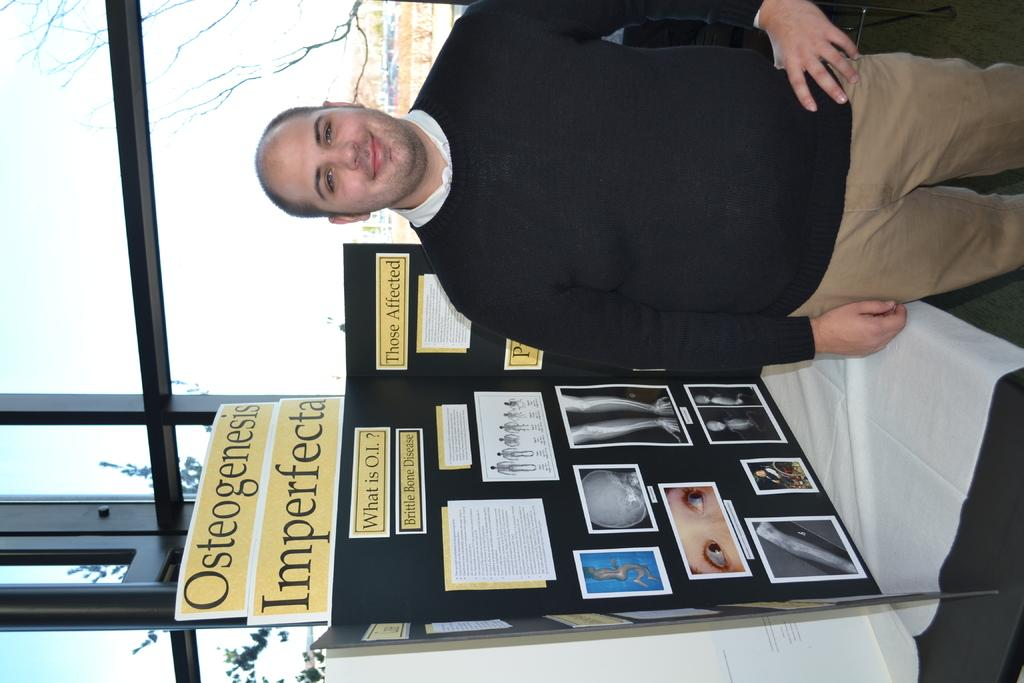<image>
Share a concise interpretation of the image provided. A man standing next to a display titled "Osteogensis Imperfecta." 